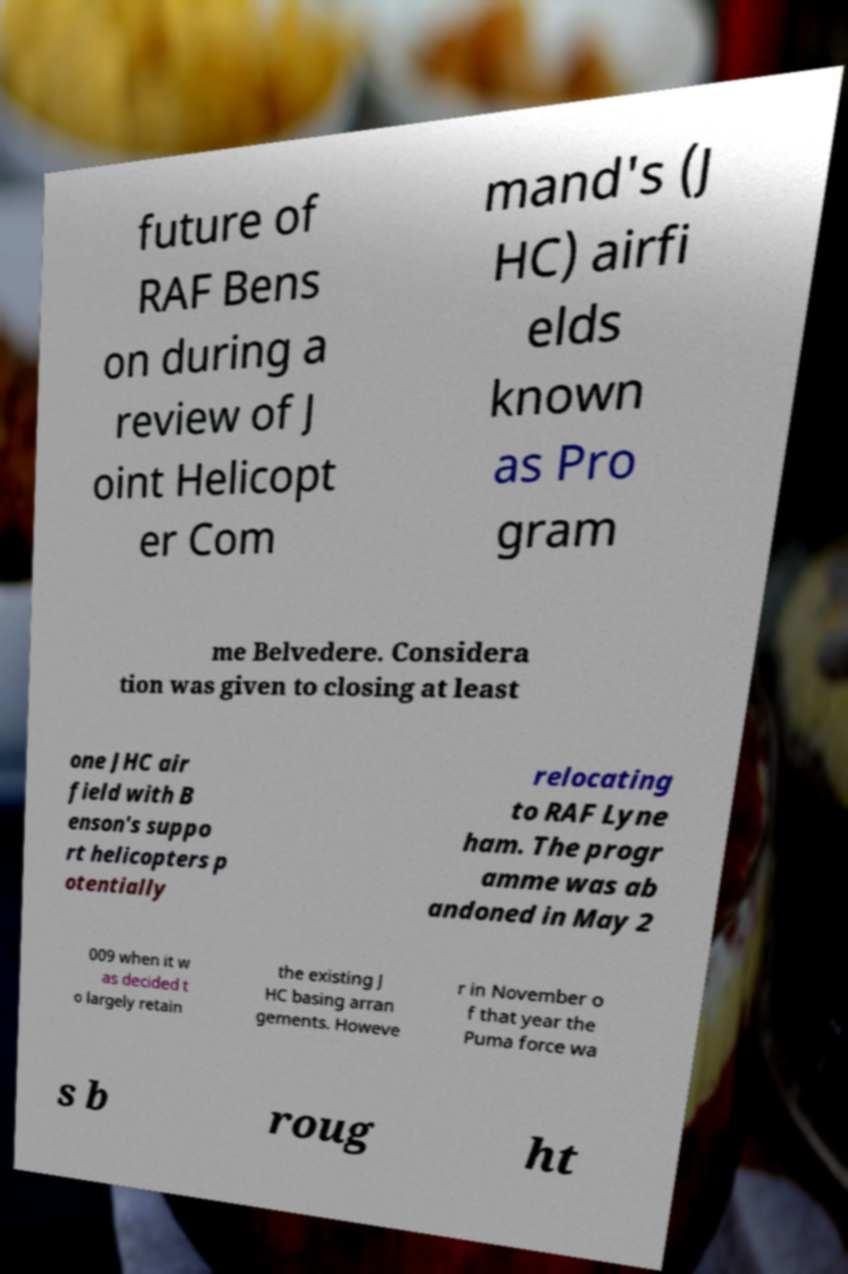Could you assist in decoding the text presented in this image and type it out clearly? future of RAF Bens on during a review of J oint Helicopt er Com mand's (J HC) airfi elds known as Pro gram me Belvedere. Considera tion was given to closing at least one JHC air field with B enson's suppo rt helicopters p otentially relocating to RAF Lyne ham. The progr amme was ab andoned in May 2 009 when it w as decided t o largely retain the existing J HC basing arran gements. Howeve r in November o f that year the Puma force wa s b roug ht 